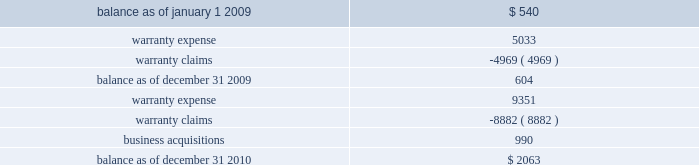On either a straight-line or accelerated basis .
Amortization expense for intangibles was approximately $ 4.2 million , $ 4.1 million and $ 4.1 million during the years ended december 31 , 2010 , 2009 and 2008 , respectively .
Estimated annual amortization expense of the december 31 , 2010 balance for the years ended december 31 , 2011 through 2015 is approximately $ 4.8 million .
Impairment of long-lived assets long-lived assets are reviewed for possible impairment whenever events or circumstances indicate that the carrying amount of such assets may not be recoverable .
If such review indicates that the carrying amount of long- lived assets is not recoverable , the carrying amount of such assets is reduced to fair value .
During the year ended december 31 , 2010 , we recognized impairment charges on certain long-lived assets during the normal course of business of $ 1.3 million .
There were no adjustments to the carrying value of long-lived assets of continuing operations during the years ended december 31 , 2009 or 2008 .
Fair value of financial instruments our debt is reflected on the balance sheet at cost .
Based on market conditions as of december 31 , 2010 , the fair value of our term loans ( see note 5 , 201clong-term obligations 201d ) reasonably approximated the carrying value of $ 590 million .
At december 31 , 2009 , the fair value of our term loans at $ 570 million was below the carrying value of $ 596 million because our interest rate margins were below the rate available in the market .
We estimated the fair value of our term loans by calculating the upfront cash payment a market participant would require to assume our obligations .
The upfront cash payment , excluding any issuance costs , is the amount that a market participant would be able to lend at december 31 , 2010 and 2009 to an entity with a credit rating similar to ours and achieve sufficient cash inflows to cover the scheduled cash outflows under our term loans .
The carrying amounts of our cash and equivalents , net trade receivables and accounts payable approximate fair value .
We apply the market and income approaches to value our financial assets and liabilities , which include the cash surrender value of life insurance , deferred compensation liabilities and interest rate swaps .
Required fair value disclosures are included in note 7 , 201cfair value measurements . 201d product warranties some of our salvage mechanical products are sold with a standard six-month warranty against defects .
Additionally , some of our remanufactured engines are sold with a standard three-year warranty against defects .
We record the estimated warranty costs at the time of sale using historical warranty claim information to project future warranty claims activity and related expenses .
The changes in the warranty reserve are as follows ( in thousands ) : .
Self-insurance reserves we self-insure a portion of employee medical benefits under the terms of our employee health insurance program .
We purchase certain stop-loss insurance to limit our liability exposure .
We also self-insure a portion of .
What was the percentage change in the changes in the warranty reserve in 2009? 
Computations: ((604 - 540) / 540)
Answer: 0.11852. 